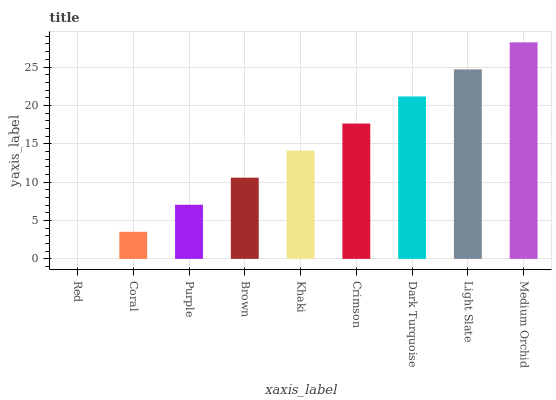Is Red the minimum?
Answer yes or no. Yes. Is Medium Orchid the maximum?
Answer yes or no. Yes. Is Coral the minimum?
Answer yes or no. No. Is Coral the maximum?
Answer yes or no. No. Is Coral greater than Red?
Answer yes or no. Yes. Is Red less than Coral?
Answer yes or no. Yes. Is Red greater than Coral?
Answer yes or no. No. Is Coral less than Red?
Answer yes or no. No. Is Khaki the high median?
Answer yes or no. Yes. Is Khaki the low median?
Answer yes or no. Yes. Is Dark Turquoise the high median?
Answer yes or no. No. Is Coral the low median?
Answer yes or no. No. 